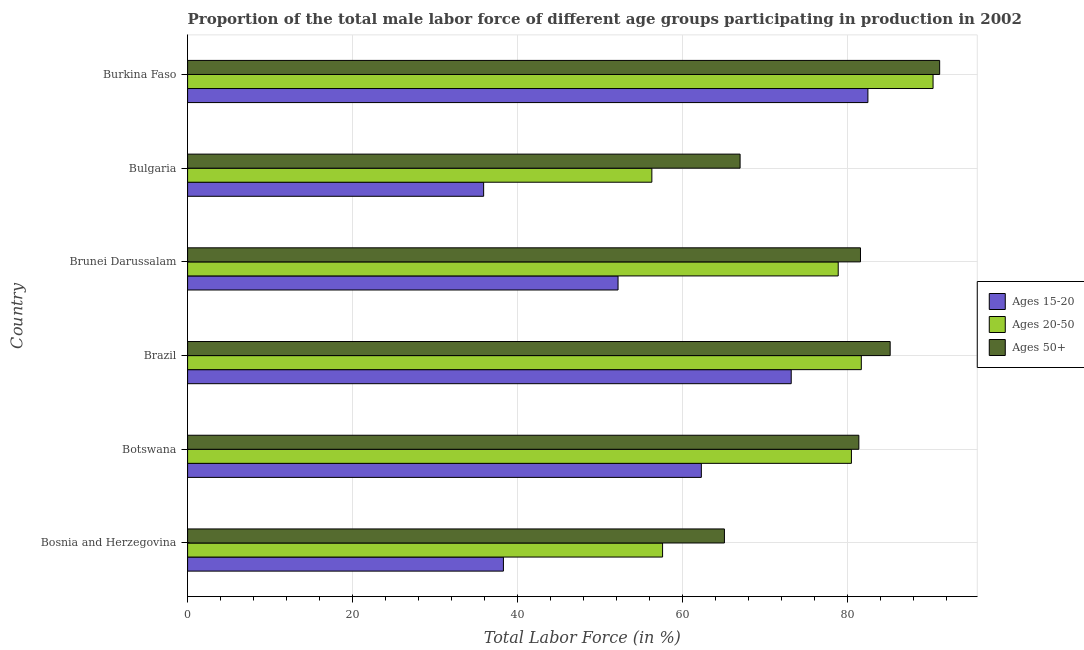How many groups of bars are there?
Keep it short and to the point. 6. Are the number of bars on each tick of the Y-axis equal?
Ensure brevity in your answer.  Yes. How many bars are there on the 4th tick from the bottom?
Keep it short and to the point. 3. What is the label of the 1st group of bars from the top?
Offer a very short reply. Burkina Faso. In how many cases, is the number of bars for a given country not equal to the number of legend labels?
Your response must be concise. 0. What is the percentage of male labor force within the age group 20-50 in Brunei Darussalam?
Provide a short and direct response. 78.9. Across all countries, what is the maximum percentage of male labor force above age 50?
Provide a short and direct response. 91.2. Across all countries, what is the minimum percentage of male labor force within the age group 15-20?
Offer a very short reply. 35.9. In which country was the percentage of male labor force within the age group 20-50 maximum?
Ensure brevity in your answer.  Burkina Faso. What is the total percentage of male labor force within the age group 15-20 in the graph?
Keep it short and to the point. 344.4. What is the difference between the percentage of male labor force within the age group 20-50 in Bosnia and Herzegovina and that in Botswana?
Your response must be concise. -22.9. What is the difference between the percentage of male labor force within the age group 15-20 in Botswana and the percentage of male labor force above age 50 in Bosnia and Herzegovina?
Ensure brevity in your answer.  -2.8. What is the average percentage of male labor force above age 50 per country?
Ensure brevity in your answer.  78.58. What is the difference between the percentage of male labor force within the age group 15-20 and percentage of male labor force above age 50 in Botswana?
Provide a short and direct response. -19.1. In how many countries, is the percentage of male labor force within the age group 15-20 greater than 64 %?
Your response must be concise. 2. What is the ratio of the percentage of male labor force within the age group 20-50 in Bosnia and Herzegovina to that in Brunei Darussalam?
Provide a succinct answer. 0.73. What is the difference between the highest and the second highest percentage of male labor force above age 50?
Your answer should be compact. 6. What is the difference between the highest and the lowest percentage of male labor force above age 50?
Give a very brief answer. 26.1. Is the sum of the percentage of male labor force within the age group 15-20 in Brazil and Bulgaria greater than the maximum percentage of male labor force within the age group 20-50 across all countries?
Your response must be concise. Yes. What does the 2nd bar from the top in Botswana represents?
Ensure brevity in your answer.  Ages 20-50. What does the 2nd bar from the bottom in Brazil represents?
Your answer should be compact. Ages 20-50. Is it the case that in every country, the sum of the percentage of male labor force within the age group 15-20 and percentage of male labor force within the age group 20-50 is greater than the percentage of male labor force above age 50?
Offer a very short reply. Yes. How many bars are there?
Ensure brevity in your answer.  18. How many countries are there in the graph?
Give a very brief answer. 6. What is the difference between two consecutive major ticks on the X-axis?
Your answer should be compact. 20. Does the graph contain any zero values?
Provide a succinct answer. No. Does the graph contain grids?
Offer a terse response. Yes. How many legend labels are there?
Keep it short and to the point. 3. What is the title of the graph?
Give a very brief answer. Proportion of the total male labor force of different age groups participating in production in 2002. Does "Taxes" appear as one of the legend labels in the graph?
Offer a terse response. No. What is the label or title of the X-axis?
Provide a short and direct response. Total Labor Force (in %). What is the label or title of the Y-axis?
Offer a very short reply. Country. What is the Total Labor Force (in %) in Ages 15-20 in Bosnia and Herzegovina?
Your answer should be very brief. 38.3. What is the Total Labor Force (in %) of Ages 20-50 in Bosnia and Herzegovina?
Your response must be concise. 57.6. What is the Total Labor Force (in %) of Ages 50+ in Bosnia and Herzegovina?
Offer a very short reply. 65.1. What is the Total Labor Force (in %) of Ages 15-20 in Botswana?
Offer a terse response. 62.3. What is the Total Labor Force (in %) in Ages 20-50 in Botswana?
Your answer should be compact. 80.5. What is the Total Labor Force (in %) in Ages 50+ in Botswana?
Your answer should be compact. 81.4. What is the Total Labor Force (in %) in Ages 15-20 in Brazil?
Give a very brief answer. 73.2. What is the Total Labor Force (in %) in Ages 20-50 in Brazil?
Ensure brevity in your answer.  81.7. What is the Total Labor Force (in %) in Ages 50+ in Brazil?
Offer a very short reply. 85.2. What is the Total Labor Force (in %) in Ages 15-20 in Brunei Darussalam?
Keep it short and to the point. 52.2. What is the Total Labor Force (in %) of Ages 20-50 in Brunei Darussalam?
Ensure brevity in your answer.  78.9. What is the Total Labor Force (in %) in Ages 50+ in Brunei Darussalam?
Make the answer very short. 81.6. What is the Total Labor Force (in %) in Ages 15-20 in Bulgaria?
Your response must be concise. 35.9. What is the Total Labor Force (in %) of Ages 20-50 in Bulgaria?
Your answer should be compact. 56.3. What is the Total Labor Force (in %) of Ages 15-20 in Burkina Faso?
Ensure brevity in your answer.  82.5. What is the Total Labor Force (in %) in Ages 20-50 in Burkina Faso?
Provide a succinct answer. 90.4. What is the Total Labor Force (in %) in Ages 50+ in Burkina Faso?
Ensure brevity in your answer.  91.2. Across all countries, what is the maximum Total Labor Force (in %) of Ages 15-20?
Give a very brief answer. 82.5. Across all countries, what is the maximum Total Labor Force (in %) in Ages 20-50?
Keep it short and to the point. 90.4. Across all countries, what is the maximum Total Labor Force (in %) in Ages 50+?
Ensure brevity in your answer.  91.2. Across all countries, what is the minimum Total Labor Force (in %) of Ages 15-20?
Offer a terse response. 35.9. Across all countries, what is the minimum Total Labor Force (in %) in Ages 20-50?
Offer a terse response. 56.3. Across all countries, what is the minimum Total Labor Force (in %) in Ages 50+?
Your answer should be compact. 65.1. What is the total Total Labor Force (in %) of Ages 15-20 in the graph?
Ensure brevity in your answer.  344.4. What is the total Total Labor Force (in %) in Ages 20-50 in the graph?
Provide a short and direct response. 445.4. What is the total Total Labor Force (in %) in Ages 50+ in the graph?
Offer a very short reply. 471.5. What is the difference between the Total Labor Force (in %) of Ages 20-50 in Bosnia and Herzegovina and that in Botswana?
Offer a very short reply. -22.9. What is the difference between the Total Labor Force (in %) in Ages 50+ in Bosnia and Herzegovina and that in Botswana?
Make the answer very short. -16.3. What is the difference between the Total Labor Force (in %) of Ages 15-20 in Bosnia and Herzegovina and that in Brazil?
Provide a succinct answer. -34.9. What is the difference between the Total Labor Force (in %) in Ages 20-50 in Bosnia and Herzegovina and that in Brazil?
Keep it short and to the point. -24.1. What is the difference between the Total Labor Force (in %) in Ages 50+ in Bosnia and Herzegovina and that in Brazil?
Offer a very short reply. -20.1. What is the difference between the Total Labor Force (in %) in Ages 15-20 in Bosnia and Herzegovina and that in Brunei Darussalam?
Offer a very short reply. -13.9. What is the difference between the Total Labor Force (in %) in Ages 20-50 in Bosnia and Herzegovina and that in Brunei Darussalam?
Ensure brevity in your answer.  -21.3. What is the difference between the Total Labor Force (in %) of Ages 50+ in Bosnia and Herzegovina and that in Brunei Darussalam?
Your answer should be compact. -16.5. What is the difference between the Total Labor Force (in %) of Ages 50+ in Bosnia and Herzegovina and that in Bulgaria?
Make the answer very short. -1.9. What is the difference between the Total Labor Force (in %) in Ages 15-20 in Bosnia and Herzegovina and that in Burkina Faso?
Your answer should be very brief. -44.2. What is the difference between the Total Labor Force (in %) of Ages 20-50 in Bosnia and Herzegovina and that in Burkina Faso?
Offer a terse response. -32.8. What is the difference between the Total Labor Force (in %) of Ages 50+ in Bosnia and Herzegovina and that in Burkina Faso?
Make the answer very short. -26.1. What is the difference between the Total Labor Force (in %) of Ages 15-20 in Botswana and that in Brazil?
Give a very brief answer. -10.9. What is the difference between the Total Labor Force (in %) in Ages 20-50 in Botswana and that in Brazil?
Give a very brief answer. -1.2. What is the difference between the Total Labor Force (in %) of Ages 15-20 in Botswana and that in Brunei Darussalam?
Your response must be concise. 10.1. What is the difference between the Total Labor Force (in %) in Ages 20-50 in Botswana and that in Brunei Darussalam?
Make the answer very short. 1.6. What is the difference between the Total Labor Force (in %) of Ages 15-20 in Botswana and that in Bulgaria?
Ensure brevity in your answer.  26.4. What is the difference between the Total Labor Force (in %) of Ages 20-50 in Botswana and that in Bulgaria?
Ensure brevity in your answer.  24.2. What is the difference between the Total Labor Force (in %) of Ages 50+ in Botswana and that in Bulgaria?
Offer a very short reply. 14.4. What is the difference between the Total Labor Force (in %) of Ages 15-20 in Botswana and that in Burkina Faso?
Ensure brevity in your answer.  -20.2. What is the difference between the Total Labor Force (in %) of Ages 20-50 in Brazil and that in Brunei Darussalam?
Your answer should be very brief. 2.8. What is the difference between the Total Labor Force (in %) of Ages 50+ in Brazil and that in Brunei Darussalam?
Keep it short and to the point. 3.6. What is the difference between the Total Labor Force (in %) of Ages 15-20 in Brazil and that in Bulgaria?
Your answer should be very brief. 37.3. What is the difference between the Total Labor Force (in %) of Ages 20-50 in Brazil and that in Bulgaria?
Give a very brief answer. 25.4. What is the difference between the Total Labor Force (in %) in Ages 20-50 in Brazil and that in Burkina Faso?
Keep it short and to the point. -8.7. What is the difference between the Total Labor Force (in %) in Ages 50+ in Brazil and that in Burkina Faso?
Offer a terse response. -6. What is the difference between the Total Labor Force (in %) of Ages 20-50 in Brunei Darussalam and that in Bulgaria?
Provide a succinct answer. 22.6. What is the difference between the Total Labor Force (in %) in Ages 50+ in Brunei Darussalam and that in Bulgaria?
Keep it short and to the point. 14.6. What is the difference between the Total Labor Force (in %) in Ages 15-20 in Brunei Darussalam and that in Burkina Faso?
Keep it short and to the point. -30.3. What is the difference between the Total Labor Force (in %) of Ages 50+ in Brunei Darussalam and that in Burkina Faso?
Give a very brief answer. -9.6. What is the difference between the Total Labor Force (in %) of Ages 15-20 in Bulgaria and that in Burkina Faso?
Your answer should be compact. -46.6. What is the difference between the Total Labor Force (in %) of Ages 20-50 in Bulgaria and that in Burkina Faso?
Give a very brief answer. -34.1. What is the difference between the Total Labor Force (in %) of Ages 50+ in Bulgaria and that in Burkina Faso?
Your answer should be compact. -24.2. What is the difference between the Total Labor Force (in %) in Ages 15-20 in Bosnia and Herzegovina and the Total Labor Force (in %) in Ages 20-50 in Botswana?
Provide a short and direct response. -42.2. What is the difference between the Total Labor Force (in %) of Ages 15-20 in Bosnia and Herzegovina and the Total Labor Force (in %) of Ages 50+ in Botswana?
Ensure brevity in your answer.  -43.1. What is the difference between the Total Labor Force (in %) of Ages 20-50 in Bosnia and Herzegovina and the Total Labor Force (in %) of Ages 50+ in Botswana?
Offer a terse response. -23.8. What is the difference between the Total Labor Force (in %) in Ages 15-20 in Bosnia and Herzegovina and the Total Labor Force (in %) in Ages 20-50 in Brazil?
Provide a succinct answer. -43.4. What is the difference between the Total Labor Force (in %) of Ages 15-20 in Bosnia and Herzegovina and the Total Labor Force (in %) of Ages 50+ in Brazil?
Give a very brief answer. -46.9. What is the difference between the Total Labor Force (in %) in Ages 20-50 in Bosnia and Herzegovina and the Total Labor Force (in %) in Ages 50+ in Brazil?
Provide a short and direct response. -27.6. What is the difference between the Total Labor Force (in %) of Ages 15-20 in Bosnia and Herzegovina and the Total Labor Force (in %) of Ages 20-50 in Brunei Darussalam?
Ensure brevity in your answer.  -40.6. What is the difference between the Total Labor Force (in %) of Ages 15-20 in Bosnia and Herzegovina and the Total Labor Force (in %) of Ages 50+ in Brunei Darussalam?
Offer a very short reply. -43.3. What is the difference between the Total Labor Force (in %) of Ages 15-20 in Bosnia and Herzegovina and the Total Labor Force (in %) of Ages 20-50 in Bulgaria?
Give a very brief answer. -18. What is the difference between the Total Labor Force (in %) in Ages 15-20 in Bosnia and Herzegovina and the Total Labor Force (in %) in Ages 50+ in Bulgaria?
Provide a short and direct response. -28.7. What is the difference between the Total Labor Force (in %) of Ages 20-50 in Bosnia and Herzegovina and the Total Labor Force (in %) of Ages 50+ in Bulgaria?
Offer a terse response. -9.4. What is the difference between the Total Labor Force (in %) in Ages 15-20 in Bosnia and Herzegovina and the Total Labor Force (in %) in Ages 20-50 in Burkina Faso?
Provide a short and direct response. -52.1. What is the difference between the Total Labor Force (in %) of Ages 15-20 in Bosnia and Herzegovina and the Total Labor Force (in %) of Ages 50+ in Burkina Faso?
Your answer should be compact. -52.9. What is the difference between the Total Labor Force (in %) in Ages 20-50 in Bosnia and Herzegovina and the Total Labor Force (in %) in Ages 50+ in Burkina Faso?
Your response must be concise. -33.6. What is the difference between the Total Labor Force (in %) of Ages 15-20 in Botswana and the Total Labor Force (in %) of Ages 20-50 in Brazil?
Offer a very short reply. -19.4. What is the difference between the Total Labor Force (in %) of Ages 15-20 in Botswana and the Total Labor Force (in %) of Ages 50+ in Brazil?
Make the answer very short. -22.9. What is the difference between the Total Labor Force (in %) of Ages 15-20 in Botswana and the Total Labor Force (in %) of Ages 20-50 in Brunei Darussalam?
Ensure brevity in your answer.  -16.6. What is the difference between the Total Labor Force (in %) in Ages 15-20 in Botswana and the Total Labor Force (in %) in Ages 50+ in Brunei Darussalam?
Offer a terse response. -19.3. What is the difference between the Total Labor Force (in %) in Ages 15-20 in Botswana and the Total Labor Force (in %) in Ages 20-50 in Bulgaria?
Provide a succinct answer. 6. What is the difference between the Total Labor Force (in %) of Ages 15-20 in Botswana and the Total Labor Force (in %) of Ages 50+ in Bulgaria?
Provide a short and direct response. -4.7. What is the difference between the Total Labor Force (in %) in Ages 15-20 in Botswana and the Total Labor Force (in %) in Ages 20-50 in Burkina Faso?
Your answer should be very brief. -28.1. What is the difference between the Total Labor Force (in %) in Ages 15-20 in Botswana and the Total Labor Force (in %) in Ages 50+ in Burkina Faso?
Ensure brevity in your answer.  -28.9. What is the difference between the Total Labor Force (in %) in Ages 15-20 in Brazil and the Total Labor Force (in %) in Ages 20-50 in Brunei Darussalam?
Give a very brief answer. -5.7. What is the difference between the Total Labor Force (in %) of Ages 20-50 in Brazil and the Total Labor Force (in %) of Ages 50+ in Brunei Darussalam?
Make the answer very short. 0.1. What is the difference between the Total Labor Force (in %) in Ages 20-50 in Brazil and the Total Labor Force (in %) in Ages 50+ in Bulgaria?
Offer a very short reply. 14.7. What is the difference between the Total Labor Force (in %) in Ages 15-20 in Brazil and the Total Labor Force (in %) in Ages 20-50 in Burkina Faso?
Your answer should be compact. -17.2. What is the difference between the Total Labor Force (in %) in Ages 15-20 in Brazil and the Total Labor Force (in %) in Ages 50+ in Burkina Faso?
Provide a succinct answer. -18. What is the difference between the Total Labor Force (in %) of Ages 20-50 in Brazil and the Total Labor Force (in %) of Ages 50+ in Burkina Faso?
Provide a short and direct response. -9.5. What is the difference between the Total Labor Force (in %) in Ages 15-20 in Brunei Darussalam and the Total Labor Force (in %) in Ages 50+ in Bulgaria?
Make the answer very short. -14.8. What is the difference between the Total Labor Force (in %) of Ages 20-50 in Brunei Darussalam and the Total Labor Force (in %) of Ages 50+ in Bulgaria?
Offer a terse response. 11.9. What is the difference between the Total Labor Force (in %) of Ages 15-20 in Brunei Darussalam and the Total Labor Force (in %) of Ages 20-50 in Burkina Faso?
Give a very brief answer. -38.2. What is the difference between the Total Labor Force (in %) of Ages 15-20 in Brunei Darussalam and the Total Labor Force (in %) of Ages 50+ in Burkina Faso?
Your answer should be very brief. -39. What is the difference between the Total Labor Force (in %) of Ages 20-50 in Brunei Darussalam and the Total Labor Force (in %) of Ages 50+ in Burkina Faso?
Provide a succinct answer. -12.3. What is the difference between the Total Labor Force (in %) of Ages 15-20 in Bulgaria and the Total Labor Force (in %) of Ages 20-50 in Burkina Faso?
Your answer should be very brief. -54.5. What is the difference between the Total Labor Force (in %) of Ages 15-20 in Bulgaria and the Total Labor Force (in %) of Ages 50+ in Burkina Faso?
Provide a succinct answer. -55.3. What is the difference between the Total Labor Force (in %) in Ages 20-50 in Bulgaria and the Total Labor Force (in %) in Ages 50+ in Burkina Faso?
Your answer should be very brief. -34.9. What is the average Total Labor Force (in %) of Ages 15-20 per country?
Your answer should be very brief. 57.4. What is the average Total Labor Force (in %) in Ages 20-50 per country?
Your response must be concise. 74.23. What is the average Total Labor Force (in %) in Ages 50+ per country?
Provide a short and direct response. 78.58. What is the difference between the Total Labor Force (in %) of Ages 15-20 and Total Labor Force (in %) of Ages 20-50 in Bosnia and Herzegovina?
Your answer should be compact. -19.3. What is the difference between the Total Labor Force (in %) in Ages 15-20 and Total Labor Force (in %) in Ages 50+ in Bosnia and Herzegovina?
Offer a terse response. -26.8. What is the difference between the Total Labor Force (in %) of Ages 20-50 and Total Labor Force (in %) of Ages 50+ in Bosnia and Herzegovina?
Your answer should be very brief. -7.5. What is the difference between the Total Labor Force (in %) in Ages 15-20 and Total Labor Force (in %) in Ages 20-50 in Botswana?
Your answer should be very brief. -18.2. What is the difference between the Total Labor Force (in %) of Ages 15-20 and Total Labor Force (in %) of Ages 50+ in Botswana?
Provide a short and direct response. -19.1. What is the difference between the Total Labor Force (in %) in Ages 20-50 and Total Labor Force (in %) in Ages 50+ in Botswana?
Keep it short and to the point. -0.9. What is the difference between the Total Labor Force (in %) in Ages 15-20 and Total Labor Force (in %) in Ages 20-50 in Brunei Darussalam?
Ensure brevity in your answer.  -26.7. What is the difference between the Total Labor Force (in %) of Ages 15-20 and Total Labor Force (in %) of Ages 50+ in Brunei Darussalam?
Your answer should be very brief. -29.4. What is the difference between the Total Labor Force (in %) in Ages 15-20 and Total Labor Force (in %) in Ages 20-50 in Bulgaria?
Offer a terse response. -20.4. What is the difference between the Total Labor Force (in %) in Ages 15-20 and Total Labor Force (in %) in Ages 50+ in Bulgaria?
Give a very brief answer. -31.1. What is the difference between the Total Labor Force (in %) in Ages 20-50 and Total Labor Force (in %) in Ages 50+ in Bulgaria?
Give a very brief answer. -10.7. What is the ratio of the Total Labor Force (in %) in Ages 15-20 in Bosnia and Herzegovina to that in Botswana?
Ensure brevity in your answer.  0.61. What is the ratio of the Total Labor Force (in %) of Ages 20-50 in Bosnia and Herzegovina to that in Botswana?
Provide a short and direct response. 0.72. What is the ratio of the Total Labor Force (in %) in Ages 50+ in Bosnia and Herzegovina to that in Botswana?
Give a very brief answer. 0.8. What is the ratio of the Total Labor Force (in %) in Ages 15-20 in Bosnia and Herzegovina to that in Brazil?
Offer a terse response. 0.52. What is the ratio of the Total Labor Force (in %) in Ages 20-50 in Bosnia and Herzegovina to that in Brazil?
Make the answer very short. 0.7. What is the ratio of the Total Labor Force (in %) in Ages 50+ in Bosnia and Herzegovina to that in Brazil?
Your answer should be very brief. 0.76. What is the ratio of the Total Labor Force (in %) of Ages 15-20 in Bosnia and Herzegovina to that in Brunei Darussalam?
Offer a terse response. 0.73. What is the ratio of the Total Labor Force (in %) in Ages 20-50 in Bosnia and Herzegovina to that in Brunei Darussalam?
Ensure brevity in your answer.  0.73. What is the ratio of the Total Labor Force (in %) of Ages 50+ in Bosnia and Herzegovina to that in Brunei Darussalam?
Offer a very short reply. 0.8. What is the ratio of the Total Labor Force (in %) of Ages 15-20 in Bosnia and Herzegovina to that in Bulgaria?
Provide a short and direct response. 1.07. What is the ratio of the Total Labor Force (in %) of Ages 20-50 in Bosnia and Herzegovina to that in Bulgaria?
Provide a short and direct response. 1.02. What is the ratio of the Total Labor Force (in %) of Ages 50+ in Bosnia and Herzegovina to that in Bulgaria?
Offer a terse response. 0.97. What is the ratio of the Total Labor Force (in %) in Ages 15-20 in Bosnia and Herzegovina to that in Burkina Faso?
Your answer should be compact. 0.46. What is the ratio of the Total Labor Force (in %) in Ages 20-50 in Bosnia and Herzegovina to that in Burkina Faso?
Your answer should be compact. 0.64. What is the ratio of the Total Labor Force (in %) of Ages 50+ in Bosnia and Herzegovina to that in Burkina Faso?
Ensure brevity in your answer.  0.71. What is the ratio of the Total Labor Force (in %) of Ages 15-20 in Botswana to that in Brazil?
Offer a very short reply. 0.85. What is the ratio of the Total Labor Force (in %) of Ages 50+ in Botswana to that in Brazil?
Offer a very short reply. 0.96. What is the ratio of the Total Labor Force (in %) in Ages 15-20 in Botswana to that in Brunei Darussalam?
Provide a short and direct response. 1.19. What is the ratio of the Total Labor Force (in %) in Ages 20-50 in Botswana to that in Brunei Darussalam?
Offer a terse response. 1.02. What is the ratio of the Total Labor Force (in %) of Ages 15-20 in Botswana to that in Bulgaria?
Keep it short and to the point. 1.74. What is the ratio of the Total Labor Force (in %) of Ages 20-50 in Botswana to that in Bulgaria?
Keep it short and to the point. 1.43. What is the ratio of the Total Labor Force (in %) of Ages 50+ in Botswana to that in Bulgaria?
Your response must be concise. 1.21. What is the ratio of the Total Labor Force (in %) in Ages 15-20 in Botswana to that in Burkina Faso?
Your response must be concise. 0.76. What is the ratio of the Total Labor Force (in %) in Ages 20-50 in Botswana to that in Burkina Faso?
Provide a succinct answer. 0.89. What is the ratio of the Total Labor Force (in %) in Ages 50+ in Botswana to that in Burkina Faso?
Provide a succinct answer. 0.89. What is the ratio of the Total Labor Force (in %) of Ages 15-20 in Brazil to that in Brunei Darussalam?
Keep it short and to the point. 1.4. What is the ratio of the Total Labor Force (in %) in Ages 20-50 in Brazil to that in Brunei Darussalam?
Provide a short and direct response. 1.04. What is the ratio of the Total Labor Force (in %) in Ages 50+ in Brazil to that in Brunei Darussalam?
Make the answer very short. 1.04. What is the ratio of the Total Labor Force (in %) of Ages 15-20 in Brazil to that in Bulgaria?
Provide a succinct answer. 2.04. What is the ratio of the Total Labor Force (in %) of Ages 20-50 in Brazil to that in Bulgaria?
Ensure brevity in your answer.  1.45. What is the ratio of the Total Labor Force (in %) of Ages 50+ in Brazil to that in Bulgaria?
Ensure brevity in your answer.  1.27. What is the ratio of the Total Labor Force (in %) in Ages 15-20 in Brazil to that in Burkina Faso?
Keep it short and to the point. 0.89. What is the ratio of the Total Labor Force (in %) of Ages 20-50 in Brazil to that in Burkina Faso?
Offer a very short reply. 0.9. What is the ratio of the Total Labor Force (in %) in Ages 50+ in Brazil to that in Burkina Faso?
Your response must be concise. 0.93. What is the ratio of the Total Labor Force (in %) in Ages 15-20 in Brunei Darussalam to that in Bulgaria?
Offer a very short reply. 1.45. What is the ratio of the Total Labor Force (in %) of Ages 20-50 in Brunei Darussalam to that in Bulgaria?
Keep it short and to the point. 1.4. What is the ratio of the Total Labor Force (in %) in Ages 50+ in Brunei Darussalam to that in Bulgaria?
Offer a terse response. 1.22. What is the ratio of the Total Labor Force (in %) in Ages 15-20 in Brunei Darussalam to that in Burkina Faso?
Give a very brief answer. 0.63. What is the ratio of the Total Labor Force (in %) of Ages 20-50 in Brunei Darussalam to that in Burkina Faso?
Offer a terse response. 0.87. What is the ratio of the Total Labor Force (in %) in Ages 50+ in Brunei Darussalam to that in Burkina Faso?
Provide a succinct answer. 0.89. What is the ratio of the Total Labor Force (in %) of Ages 15-20 in Bulgaria to that in Burkina Faso?
Your answer should be compact. 0.44. What is the ratio of the Total Labor Force (in %) in Ages 20-50 in Bulgaria to that in Burkina Faso?
Your answer should be very brief. 0.62. What is the ratio of the Total Labor Force (in %) in Ages 50+ in Bulgaria to that in Burkina Faso?
Offer a terse response. 0.73. What is the difference between the highest and the second highest Total Labor Force (in %) in Ages 20-50?
Offer a very short reply. 8.7. What is the difference between the highest and the lowest Total Labor Force (in %) in Ages 15-20?
Your answer should be compact. 46.6. What is the difference between the highest and the lowest Total Labor Force (in %) in Ages 20-50?
Provide a short and direct response. 34.1. What is the difference between the highest and the lowest Total Labor Force (in %) in Ages 50+?
Your answer should be compact. 26.1. 